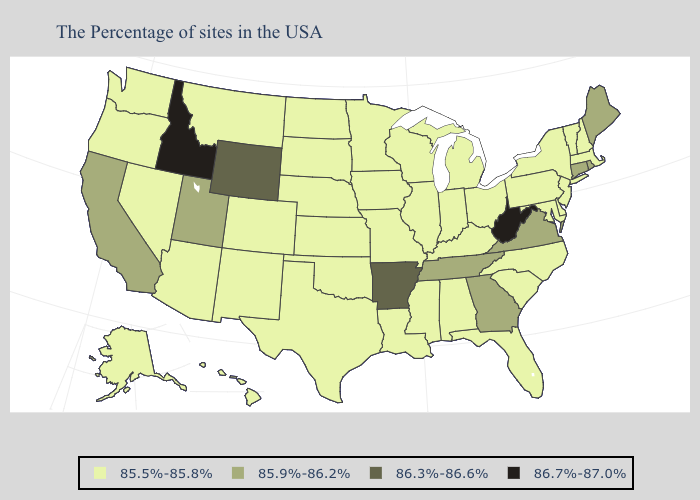Does Utah have a higher value than Maine?
Keep it brief. No. Which states hav the highest value in the South?
Be succinct. West Virginia. What is the highest value in states that border Connecticut?
Give a very brief answer. 85.9%-86.2%. Name the states that have a value in the range 86.3%-86.6%?
Short answer required. Arkansas, Wyoming. What is the value of California?
Quick response, please. 85.9%-86.2%. Which states have the lowest value in the USA?
Concise answer only. Massachusetts, New Hampshire, Vermont, New York, New Jersey, Delaware, Maryland, Pennsylvania, North Carolina, South Carolina, Ohio, Florida, Michigan, Kentucky, Indiana, Alabama, Wisconsin, Illinois, Mississippi, Louisiana, Missouri, Minnesota, Iowa, Kansas, Nebraska, Oklahoma, Texas, South Dakota, North Dakota, Colorado, New Mexico, Montana, Arizona, Nevada, Washington, Oregon, Alaska, Hawaii. Among the states that border Louisiana , which have the lowest value?
Be succinct. Mississippi, Texas. Does California have a lower value than West Virginia?
Keep it brief. Yes. What is the value of Ohio?
Be succinct. 85.5%-85.8%. Among the states that border North Carolina , which have the highest value?
Concise answer only. Virginia, Georgia, Tennessee. Which states hav the highest value in the Northeast?
Give a very brief answer. Maine, Rhode Island, Connecticut. Which states have the lowest value in the West?
Concise answer only. Colorado, New Mexico, Montana, Arizona, Nevada, Washington, Oregon, Alaska, Hawaii. What is the value of Illinois?
Concise answer only. 85.5%-85.8%. What is the value of Utah?
Concise answer only. 85.9%-86.2%. Name the states that have a value in the range 85.9%-86.2%?
Write a very short answer. Maine, Rhode Island, Connecticut, Virginia, Georgia, Tennessee, Utah, California. 